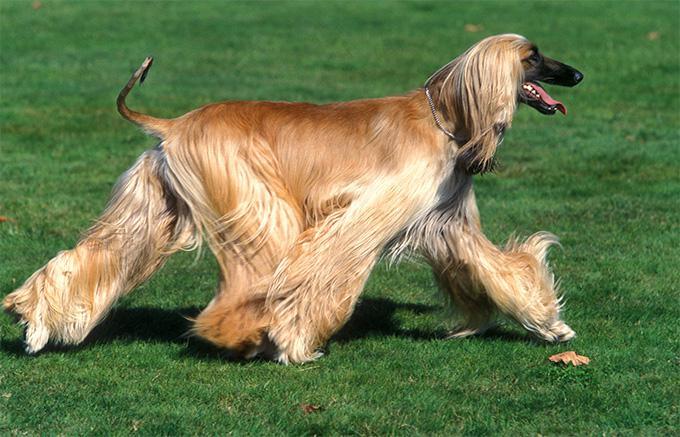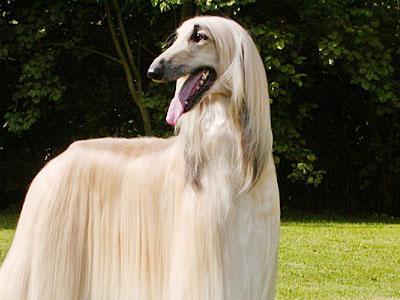The first image is the image on the left, the second image is the image on the right. Analyze the images presented: Is the assertion "Only the left image shows a dog on a grassy area." valid? Answer yes or no. No. 